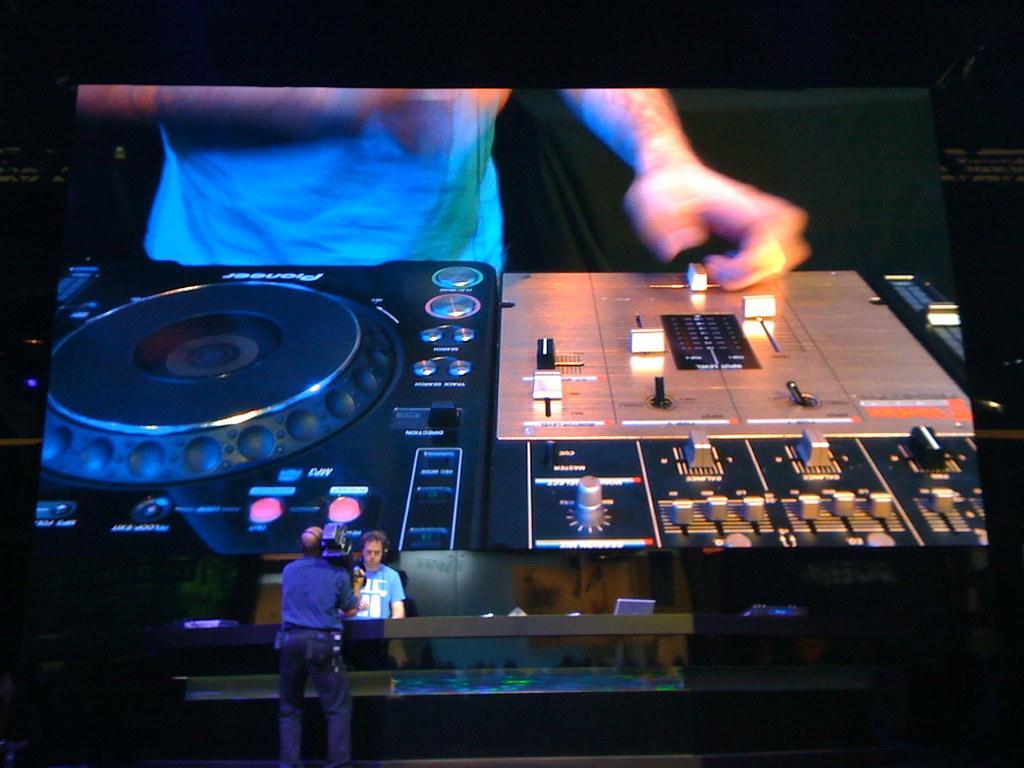In one or two sentences, can you explain what this image depicts? In this picture I can observe large screen in the middle of the picture. In the screen there is an electronic device. In the bottom of the picture I can observe two men. One of them is holding a video camera in his hands. The background is completely dark. 